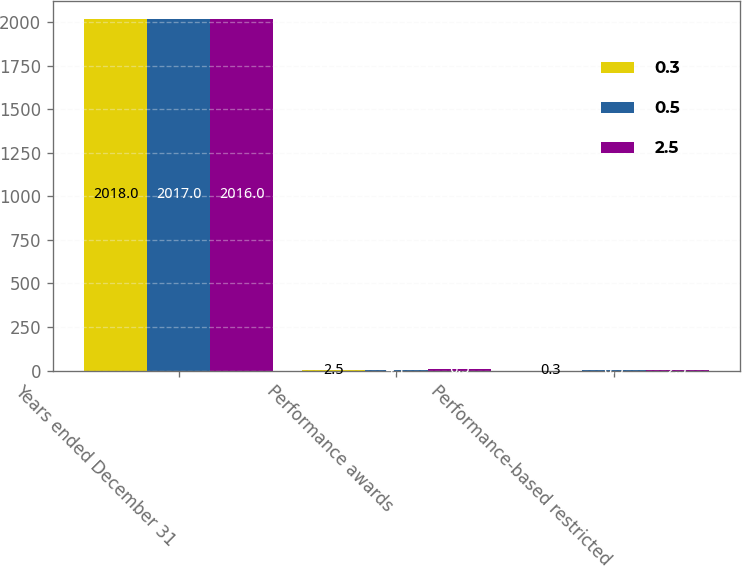Convert chart. <chart><loc_0><loc_0><loc_500><loc_500><stacked_bar_chart><ecel><fcel>Years ended December 31<fcel>Performance awards<fcel>Performance-based restricted<nl><fcel>0.3<fcel>2018<fcel>2.5<fcel>0.3<nl><fcel>0.5<fcel>2017<fcel>4.1<fcel>0.5<nl><fcel>2.5<fcel>2016<fcel>6.5<fcel>2.5<nl></chart> 